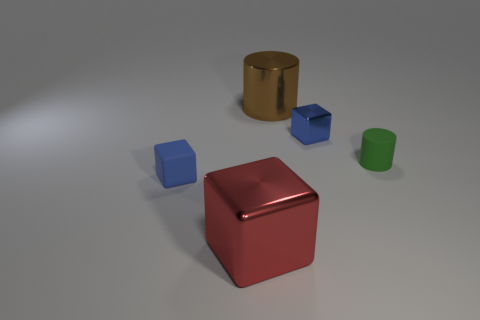Are there any large brown shiny objects that have the same shape as the large red metal thing? No, there are no large brown shiny objects that share the same cubic shape as the large red metal cube in the image. However, there is a smaller, shiny golden cylinder, as well as smaller blue cubes and a green cylinder that are part of this collection of objects. 